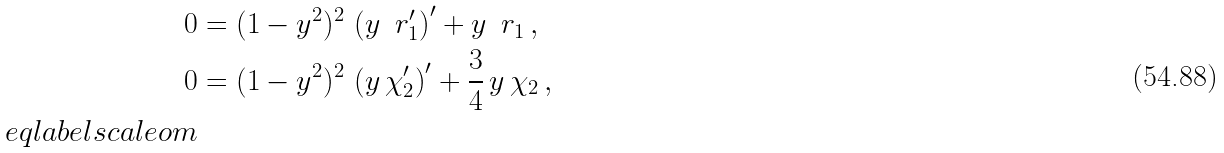<formula> <loc_0><loc_0><loc_500><loc_500>0 & = ( 1 - y ^ { 2 } ) ^ { 2 } \, \left ( y \, \ r _ { 1 } ^ { \prime } \right ) ^ { \prime } + y \, \ r _ { 1 } \, , \\ 0 & = ( 1 - y ^ { 2 } ) ^ { 2 } \, \left ( y \, \chi _ { 2 } ^ { \prime } \right ) ^ { \prime } + \frac { 3 } { 4 } \, y \, \chi _ { 2 } \, , \\ \ e q l a b e l { s c a l e o m }</formula> 